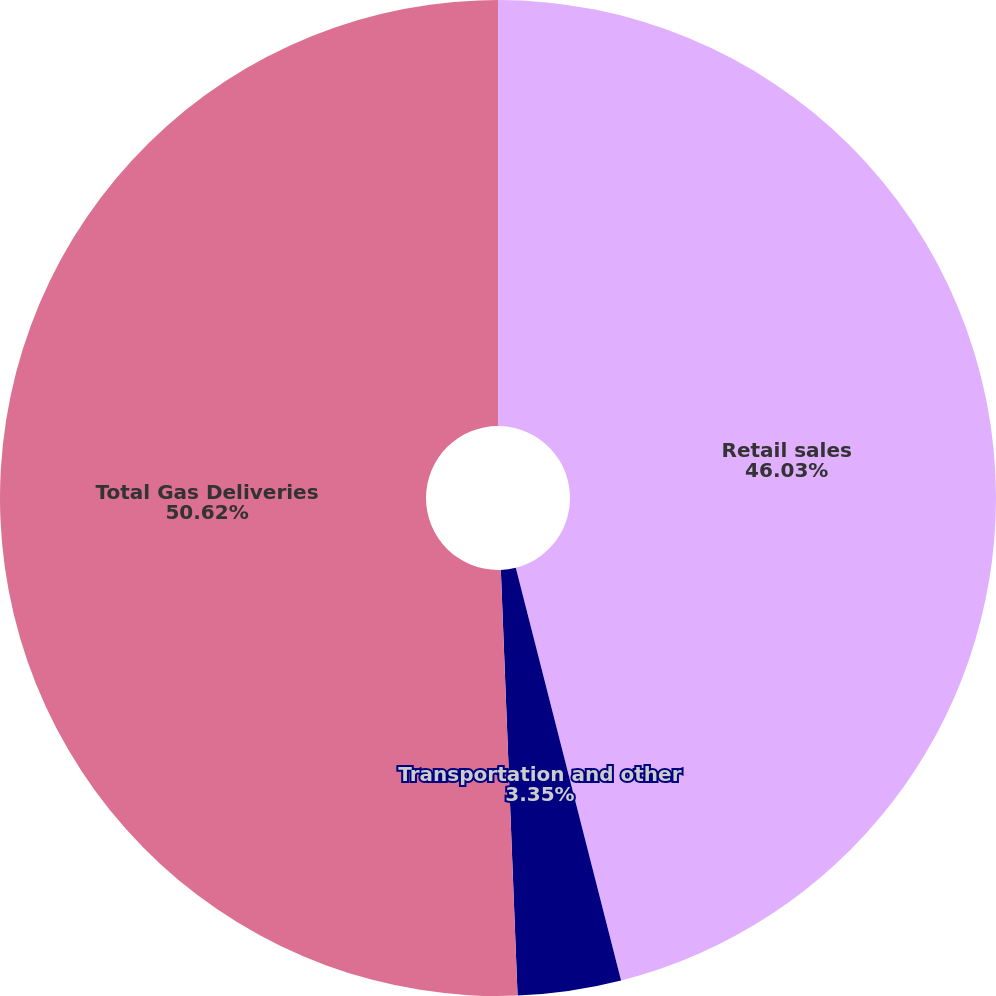Convert chart. <chart><loc_0><loc_0><loc_500><loc_500><pie_chart><fcel>Retail sales<fcel>Transportation and other<fcel>Total Gas Deliveries<nl><fcel>46.03%<fcel>3.35%<fcel>50.63%<nl></chart> 